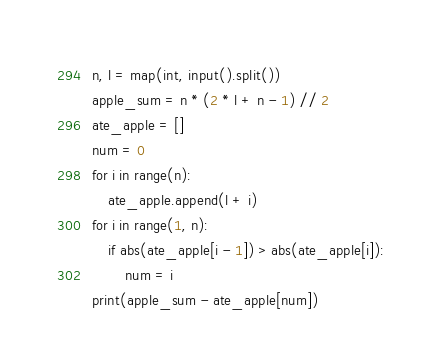<code> <loc_0><loc_0><loc_500><loc_500><_Python_>n, l = map(int, input().split())
apple_sum = n * (2 * l + n - 1) // 2
ate_apple = []
num = 0
for i in range(n):
    ate_apple.append(l + i)
for i in range(1, n):
    if abs(ate_apple[i - 1]) > abs(ate_apple[i]):
        num = i
print(apple_sum - ate_apple[num])</code> 